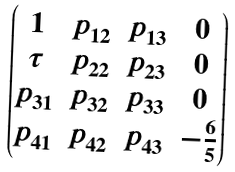<formula> <loc_0><loc_0><loc_500><loc_500>\begin{pmatrix} 1 & p _ { 1 2 } & p _ { 1 3 } & 0 \\ \tau & p _ { 2 2 } & p _ { 2 3 } & 0 \\ p _ { 3 1 } & p _ { 3 2 } & p _ { 3 3 } & 0 \\ p _ { 4 1 } & p _ { 4 2 } & p _ { 4 3 } & - \frac { 6 } { 5 } \\ \end{pmatrix}</formula> 